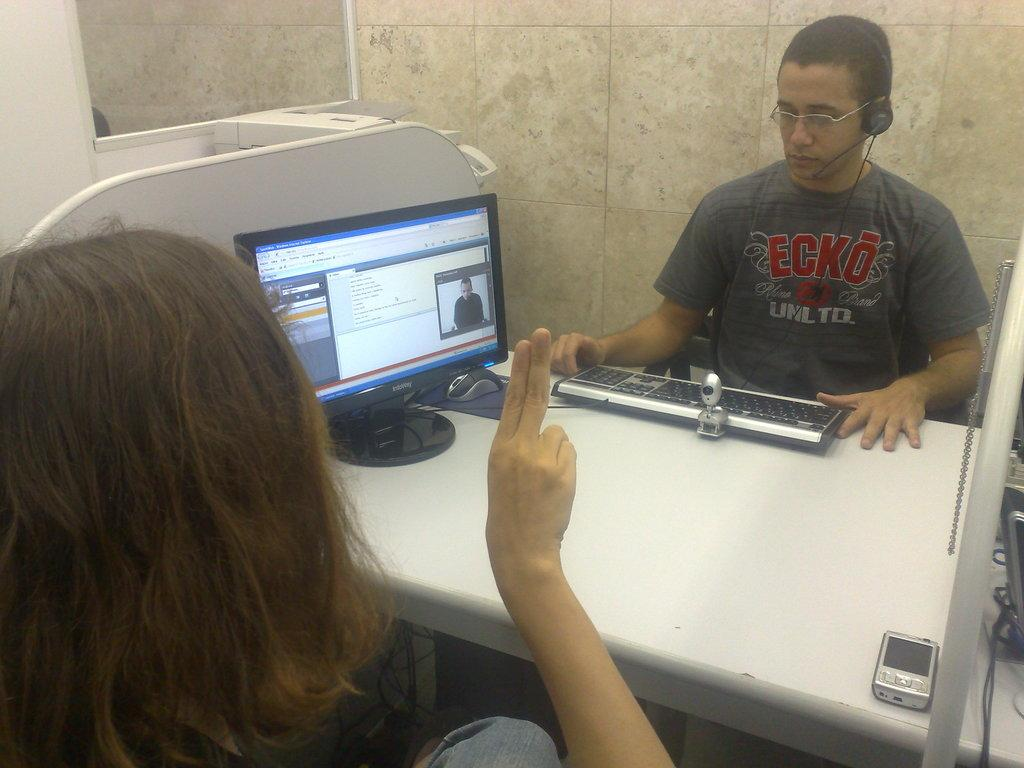<image>
Write a terse but informative summary of the picture. Infoway computer monitor with Windows Internet Explorer home page. 